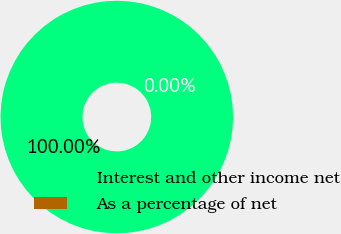Convert chart. <chart><loc_0><loc_0><loc_500><loc_500><pie_chart><fcel>Interest and other income net<fcel>As a percentage of net<nl><fcel>100.0%<fcel>0.0%<nl></chart> 